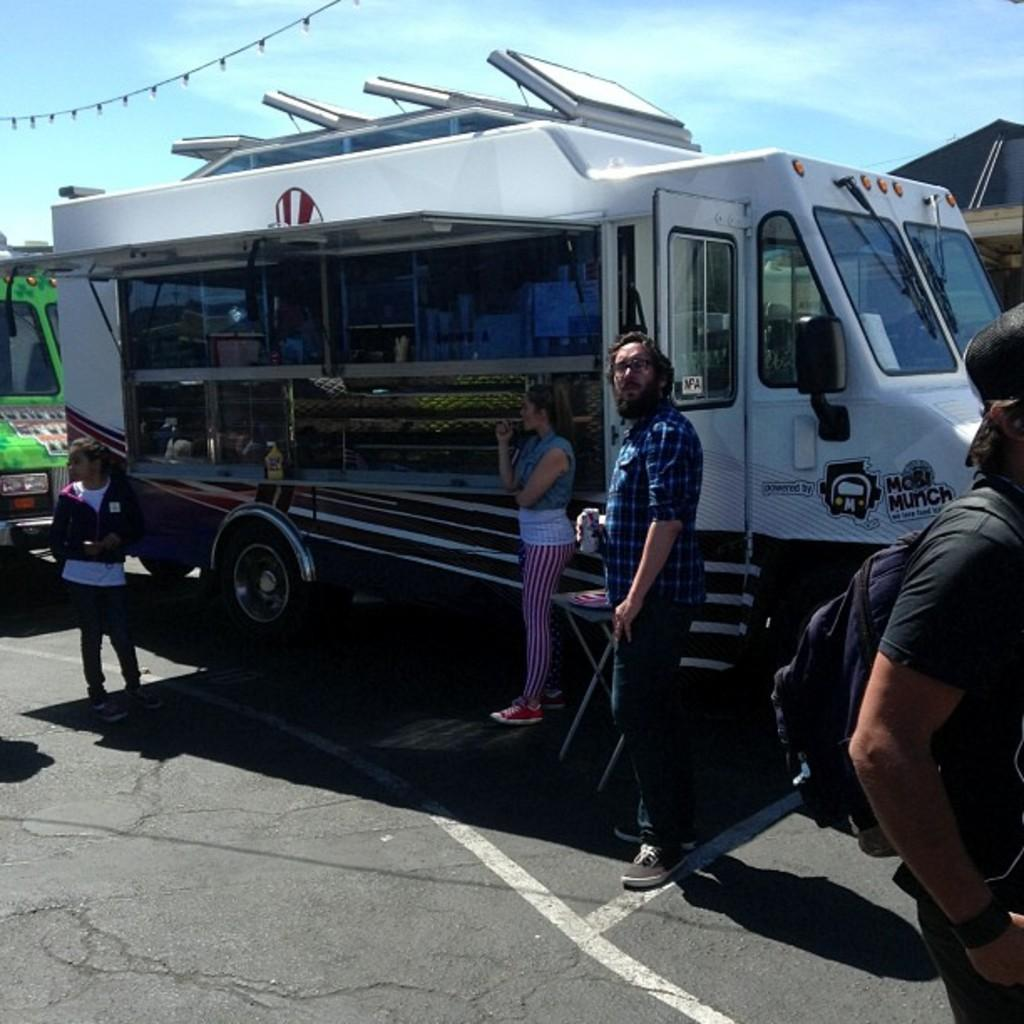What is the main subject of the image? The main subject of the image is a food truck. Where is the food truck located in the image? The food truck is in the middle of the image. What can be seen near the food truck? There are people standing near the food truck. What is the condition of the sky in the image? The sky is visible at the top of the image. Can you see any veins on the food truck in the image? There are no veins present on the food truck in the image. Are there any deer visible near the food truck in the image? There are no deer present near the food truck in the image. 